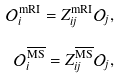Convert formula to latex. <formula><loc_0><loc_0><loc_500><loc_500>\mathcal { O } ^ { \text {mRI} } _ { i } = Z ^ { \text {mRI} } _ { i j } \mathcal { O } _ { j } , \\ \mathcal { O } ^ { \overline { \text {MS} } } _ { i } = Z ^ { \overline { \text {MS} } } _ { i j } \mathcal { O } _ { j } ,</formula> 